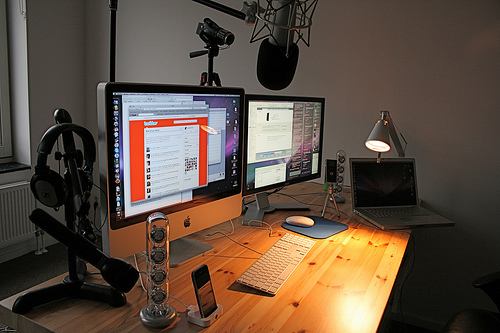<image>
Is there a computer in front of the table? No. The computer is not in front of the table. The spatial positioning shows a different relationship between these objects. Is the camera above the phone? No. The camera is not positioned above the phone. The vertical arrangement shows a different relationship. 